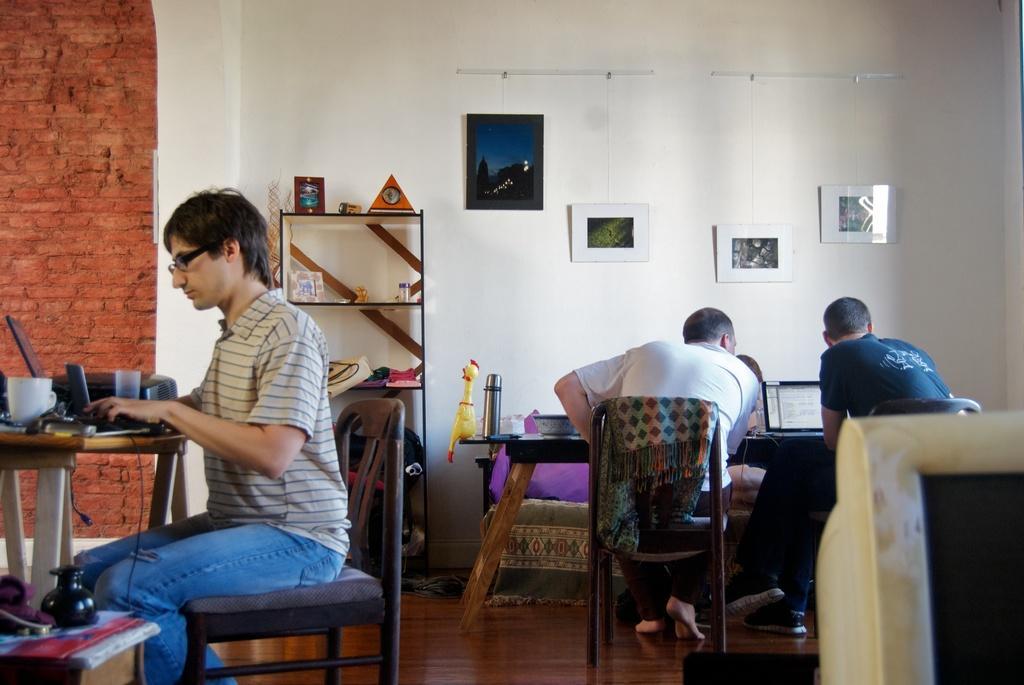How would you summarize this image in a sentence or two? In the picture we can find three persons, one person is sitting on a chair and doing something on the table and in the back side we can find two people sitting in the chairs and working, background we can find a wall, to side we can also find a brick wall and photos attached to it. 